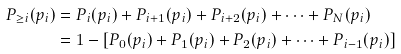Convert formula to latex. <formula><loc_0><loc_0><loc_500><loc_500>P _ { \geq i } ( p _ { i } ) & = P _ { i } ( p _ { i } ) + P _ { i + 1 } ( p _ { i } ) + P _ { i + 2 } ( p _ { i } ) + \dots + P _ { N } ( p _ { i } ) \\ & = 1 - [ P _ { 0 } ( p _ { i } ) + P _ { 1 } ( p _ { i } ) + P _ { 2 } ( p _ { i } ) + \dots + P _ { i - 1 } ( p _ { i } ) ]</formula> 